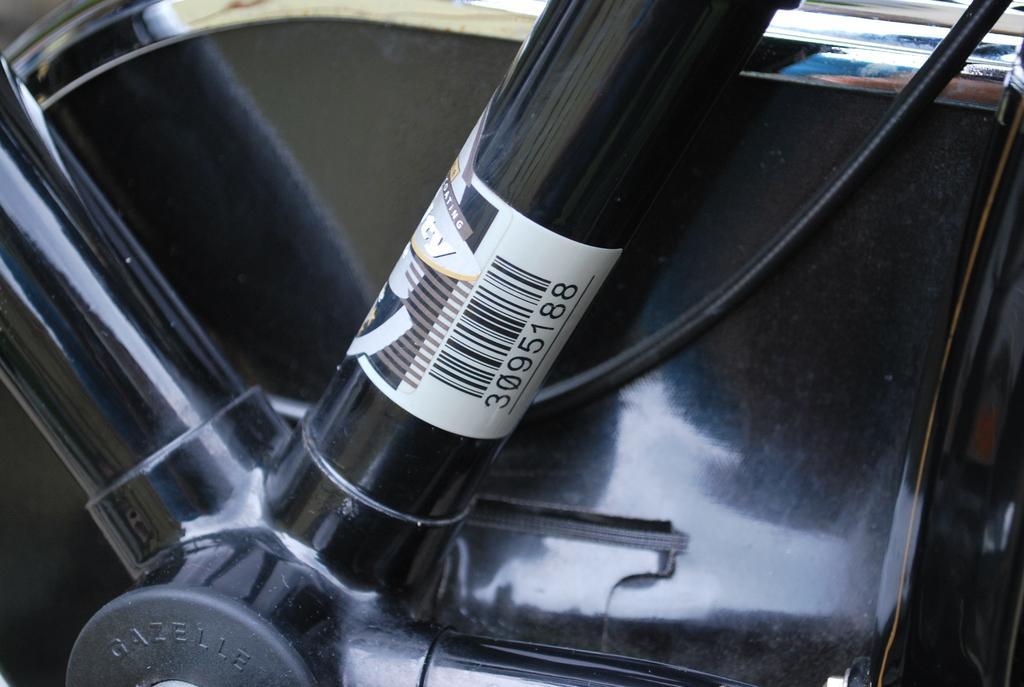Could you give a brief overview of what you see in this image? In this image may be there is a vehicle part, on which there is a label, in which there is a barcode contain numbers on it. 